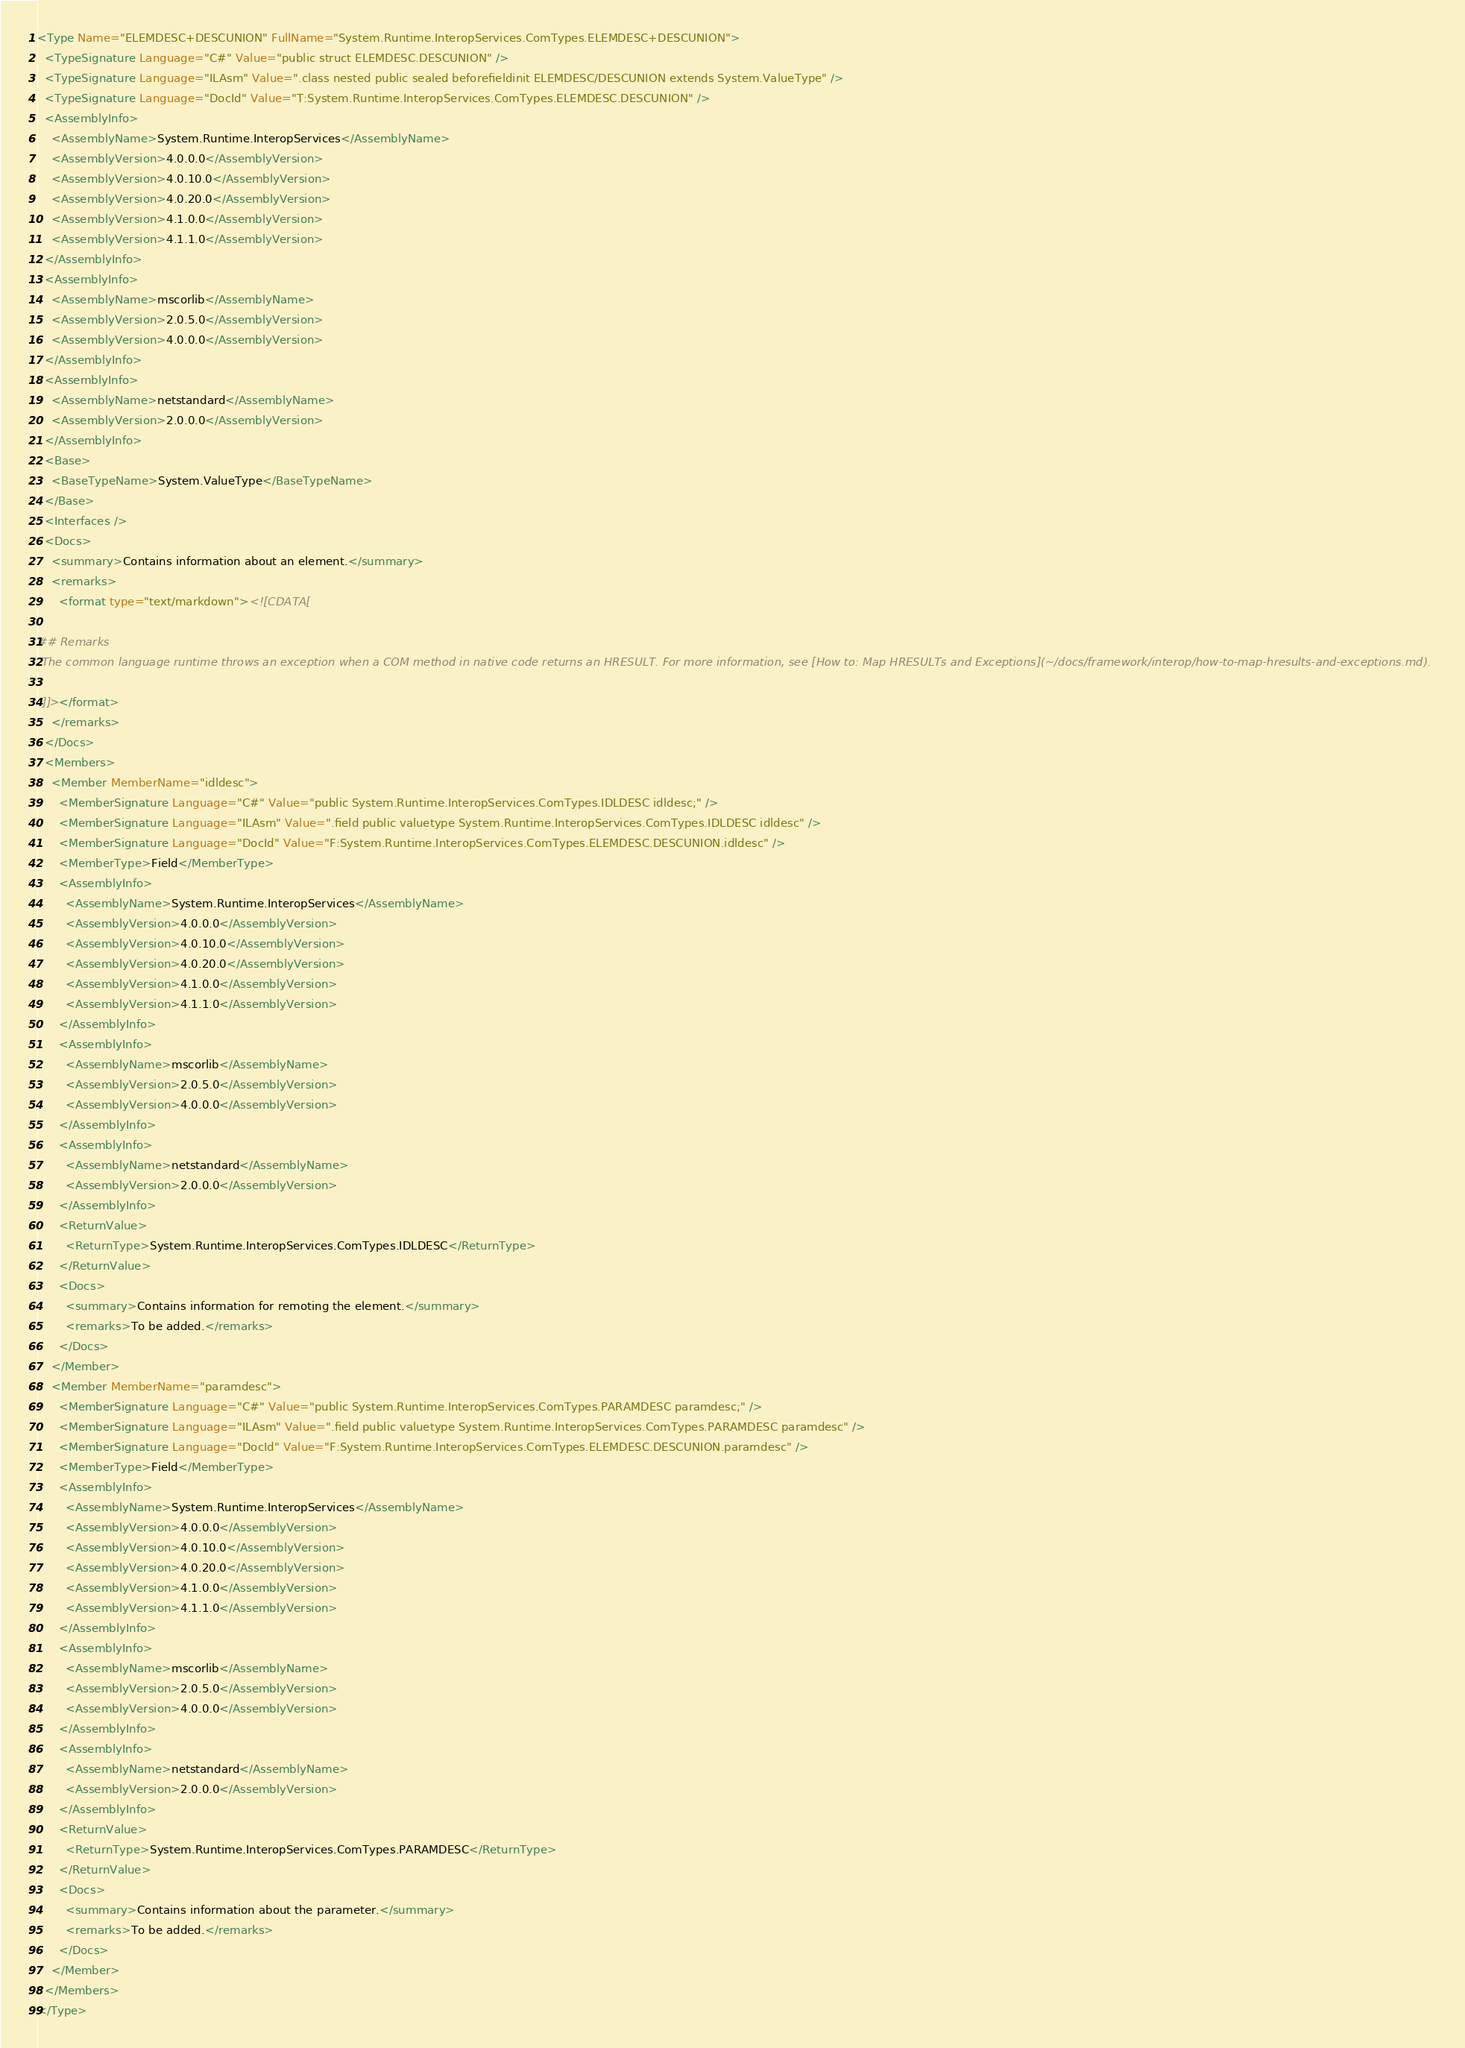Convert code to text. <code><loc_0><loc_0><loc_500><loc_500><_XML_><Type Name="ELEMDESC+DESCUNION" FullName="System.Runtime.InteropServices.ComTypes.ELEMDESC+DESCUNION">
  <TypeSignature Language="C#" Value="public struct ELEMDESC.DESCUNION" />
  <TypeSignature Language="ILAsm" Value=".class nested public sealed beforefieldinit ELEMDESC/DESCUNION extends System.ValueType" />
  <TypeSignature Language="DocId" Value="T:System.Runtime.InteropServices.ComTypes.ELEMDESC.DESCUNION" />
  <AssemblyInfo>
    <AssemblyName>System.Runtime.InteropServices</AssemblyName>
    <AssemblyVersion>4.0.0.0</AssemblyVersion>
    <AssemblyVersion>4.0.10.0</AssemblyVersion>
    <AssemblyVersion>4.0.20.0</AssemblyVersion>
    <AssemblyVersion>4.1.0.0</AssemblyVersion>
    <AssemblyVersion>4.1.1.0</AssemblyVersion>
  </AssemblyInfo>
  <AssemblyInfo>
    <AssemblyName>mscorlib</AssemblyName>
    <AssemblyVersion>2.0.5.0</AssemblyVersion>
    <AssemblyVersion>4.0.0.0</AssemblyVersion>
  </AssemblyInfo>
  <AssemblyInfo>
    <AssemblyName>netstandard</AssemblyName>
    <AssemblyVersion>2.0.0.0</AssemblyVersion>
  </AssemblyInfo>
  <Base>
    <BaseTypeName>System.ValueType</BaseTypeName>
  </Base>
  <Interfaces />
  <Docs>
    <summary>Contains information about an element.</summary>
    <remarks>
      <format type="text/markdown"><![CDATA[  
  
## Remarks  
 The common language runtime throws an exception when a COM method in native code returns an HRESULT. For more information, see [How to: Map HRESULTs and Exceptions](~/docs/framework/interop/how-to-map-hresults-and-exceptions.md).  
  
 ]]></format>
    </remarks>
  </Docs>
  <Members>
    <Member MemberName="idldesc">
      <MemberSignature Language="C#" Value="public System.Runtime.InteropServices.ComTypes.IDLDESC idldesc;" />
      <MemberSignature Language="ILAsm" Value=".field public valuetype System.Runtime.InteropServices.ComTypes.IDLDESC idldesc" />
      <MemberSignature Language="DocId" Value="F:System.Runtime.InteropServices.ComTypes.ELEMDESC.DESCUNION.idldesc" />
      <MemberType>Field</MemberType>
      <AssemblyInfo>
        <AssemblyName>System.Runtime.InteropServices</AssemblyName>
        <AssemblyVersion>4.0.0.0</AssemblyVersion>
        <AssemblyVersion>4.0.10.0</AssemblyVersion>
        <AssemblyVersion>4.0.20.0</AssemblyVersion>
        <AssemblyVersion>4.1.0.0</AssemblyVersion>
        <AssemblyVersion>4.1.1.0</AssemblyVersion>
      </AssemblyInfo>
      <AssemblyInfo>
        <AssemblyName>mscorlib</AssemblyName>
        <AssemblyVersion>2.0.5.0</AssemblyVersion>
        <AssemblyVersion>4.0.0.0</AssemblyVersion>
      </AssemblyInfo>
      <AssemblyInfo>
        <AssemblyName>netstandard</AssemblyName>
        <AssemblyVersion>2.0.0.0</AssemblyVersion>
      </AssemblyInfo>
      <ReturnValue>
        <ReturnType>System.Runtime.InteropServices.ComTypes.IDLDESC</ReturnType>
      </ReturnValue>
      <Docs>
        <summary>Contains information for remoting the element.</summary>
        <remarks>To be added.</remarks>
      </Docs>
    </Member>
    <Member MemberName="paramdesc">
      <MemberSignature Language="C#" Value="public System.Runtime.InteropServices.ComTypes.PARAMDESC paramdesc;" />
      <MemberSignature Language="ILAsm" Value=".field public valuetype System.Runtime.InteropServices.ComTypes.PARAMDESC paramdesc" />
      <MemberSignature Language="DocId" Value="F:System.Runtime.InteropServices.ComTypes.ELEMDESC.DESCUNION.paramdesc" />
      <MemberType>Field</MemberType>
      <AssemblyInfo>
        <AssemblyName>System.Runtime.InteropServices</AssemblyName>
        <AssemblyVersion>4.0.0.0</AssemblyVersion>
        <AssemblyVersion>4.0.10.0</AssemblyVersion>
        <AssemblyVersion>4.0.20.0</AssemblyVersion>
        <AssemblyVersion>4.1.0.0</AssemblyVersion>
        <AssemblyVersion>4.1.1.0</AssemblyVersion>
      </AssemblyInfo>
      <AssemblyInfo>
        <AssemblyName>mscorlib</AssemblyName>
        <AssemblyVersion>2.0.5.0</AssemblyVersion>
        <AssemblyVersion>4.0.0.0</AssemblyVersion>
      </AssemblyInfo>
      <AssemblyInfo>
        <AssemblyName>netstandard</AssemblyName>
        <AssemblyVersion>2.0.0.0</AssemblyVersion>
      </AssemblyInfo>
      <ReturnValue>
        <ReturnType>System.Runtime.InteropServices.ComTypes.PARAMDESC</ReturnType>
      </ReturnValue>
      <Docs>
        <summary>Contains information about the parameter.</summary>
        <remarks>To be added.</remarks>
      </Docs>
    </Member>
  </Members>
</Type>
</code> 